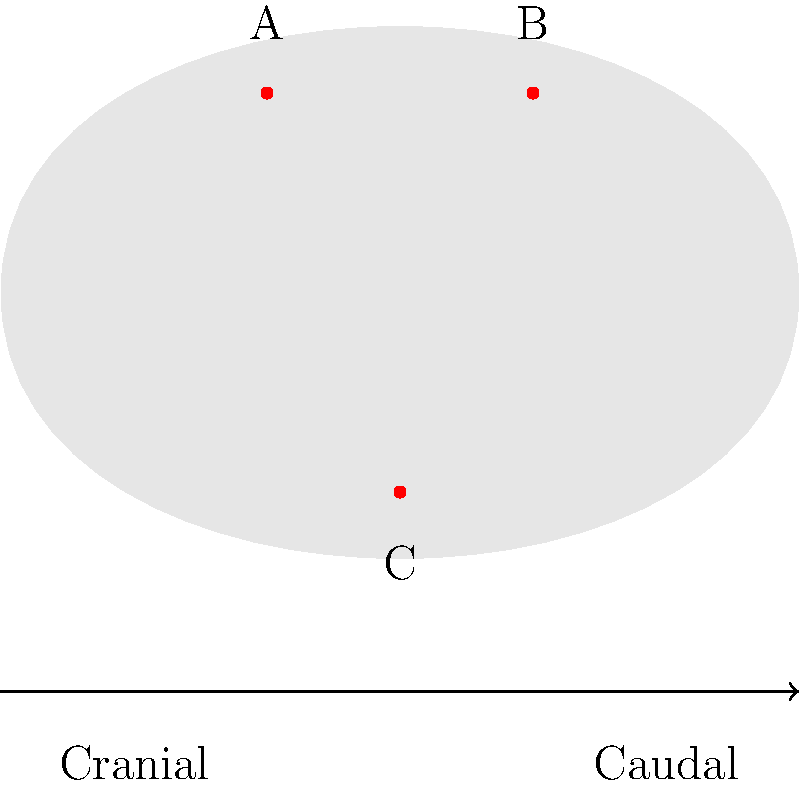In the diagram above, which represents the proper placement of electrodes for electro-ejaculation in bulls, what is the correct positioning of the electrodes labeled A, B, and C? To understand the correct positioning of electrodes for electro-ejaculation in bulls, we need to follow these steps:

1. Electrode placement is crucial for effective and safe electro-ejaculation in bulls.

2. The diagram shows a side view of a bull with three electrodes labeled A, B, and C.

3. Two electrodes (A and B) are positioned on the dorsal (upper) side of the bull, while one electrode (C) is on the ventral (lower) side.

4. The correct placement is:
   - Electrodes A and B should be placed on the dorsal aspect of the bull's pelvis, lateral to the midline.
   - Electrode C should be placed on the ventral aspect of the bull's pelvis, near the base of the scrotum.

5. This triangular configuration ensures that the electrical current passes through the pelvic region, stimulating the nerves responsible for ejaculation.

6. The placement of A and B on the dorsal side allows for stimulation of the hypogastric and pelvic nerves.

7. Electrode C on the ventral side completes the circuit and helps stimulate the pudendal nerve.

8. The cranial-caudal orientation shown in the diagram is important, as it indicates that electrodes A and B should be placed more cranially (towards the head) than electrode C.

Therefore, the correct positioning is: A and B on the dorsal aspect of the pelvis, lateral to the midline, and C on the ventral aspect near the base of the scrotum.
Answer: A and B dorsal, lateral to midline; C ventral, near scrotum base 